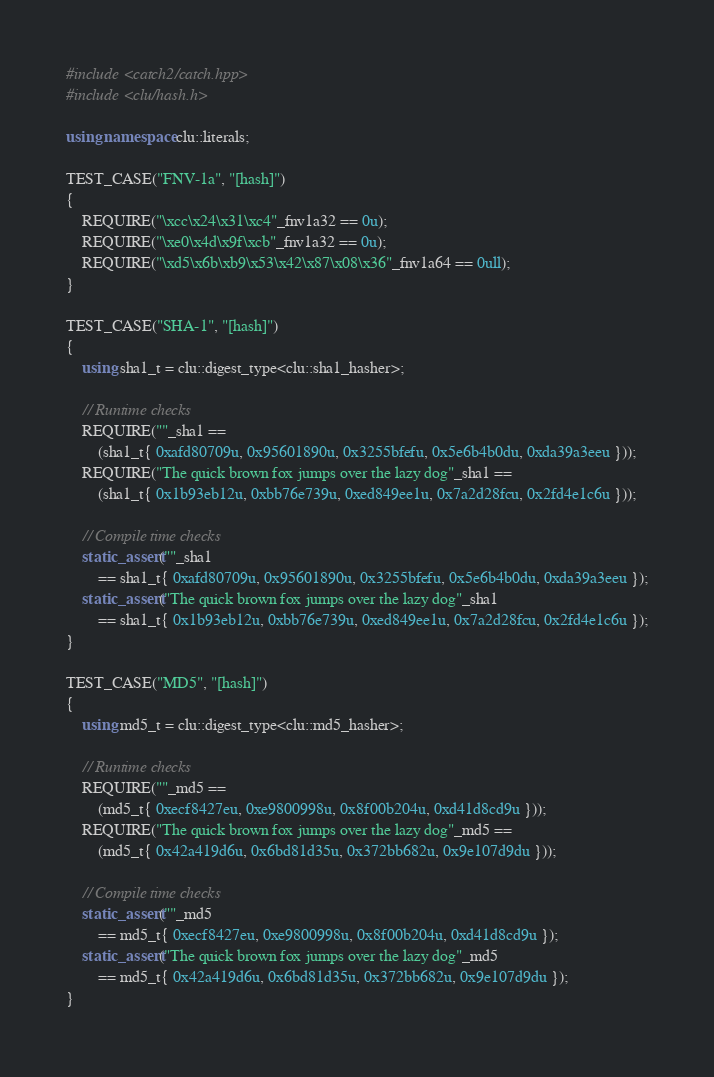Convert code to text. <code><loc_0><loc_0><loc_500><loc_500><_C++_>#include <catch2/catch.hpp>
#include <clu/hash.h>

using namespace clu::literals;

TEST_CASE("FNV-1a", "[hash]")
{
    REQUIRE("\xcc\x24\x31\xc4"_fnv1a32 == 0u);
    REQUIRE("\xe0\x4d\x9f\xcb"_fnv1a32 == 0u);
    REQUIRE("\xd5\x6b\xb9\x53\x42\x87\x08\x36"_fnv1a64 == 0ull);
}

TEST_CASE("SHA-1", "[hash]")
{
    using sha1_t = clu::digest_type<clu::sha1_hasher>;

    // Runtime checks
    REQUIRE(""_sha1 ==
        (sha1_t{ 0xafd80709u, 0x95601890u, 0x3255bfefu, 0x5e6b4b0du, 0xda39a3eeu }));
    REQUIRE("The quick brown fox jumps over the lazy dog"_sha1 ==
        (sha1_t{ 0x1b93eb12u, 0xbb76e739u, 0xed849ee1u, 0x7a2d28fcu, 0x2fd4e1c6u }));

    // Compile time checks
    static_assert(""_sha1
        == sha1_t{ 0xafd80709u, 0x95601890u, 0x3255bfefu, 0x5e6b4b0du, 0xda39a3eeu });
    static_assert("The quick brown fox jumps over the lazy dog"_sha1
        == sha1_t{ 0x1b93eb12u, 0xbb76e739u, 0xed849ee1u, 0x7a2d28fcu, 0x2fd4e1c6u });
}

TEST_CASE("MD5", "[hash]")
{
    using md5_t = clu::digest_type<clu::md5_hasher>;

    // Runtime checks
    REQUIRE(""_md5 ==
        (md5_t{ 0xecf8427eu, 0xe9800998u, 0x8f00b204u, 0xd41d8cd9u }));
    REQUIRE("The quick brown fox jumps over the lazy dog"_md5 ==
        (md5_t{ 0x42a419d6u, 0x6bd81d35u, 0x372bb682u, 0x9e107d9du }));

    // Compile time checks
    static_assert(""_md5
        == md5_t{ 0xecf8427eu, 0xe9800998u, 0x8f00b204u, 0xd41d8cd9u });
    static_assert("The quick brown fox jumps over the lazy dog"_md5
        == md5_t{ 0x42a419d6u, 0x6bd81d35u, 0x372bb682u, 0x9e107d9du });
}
</code> 